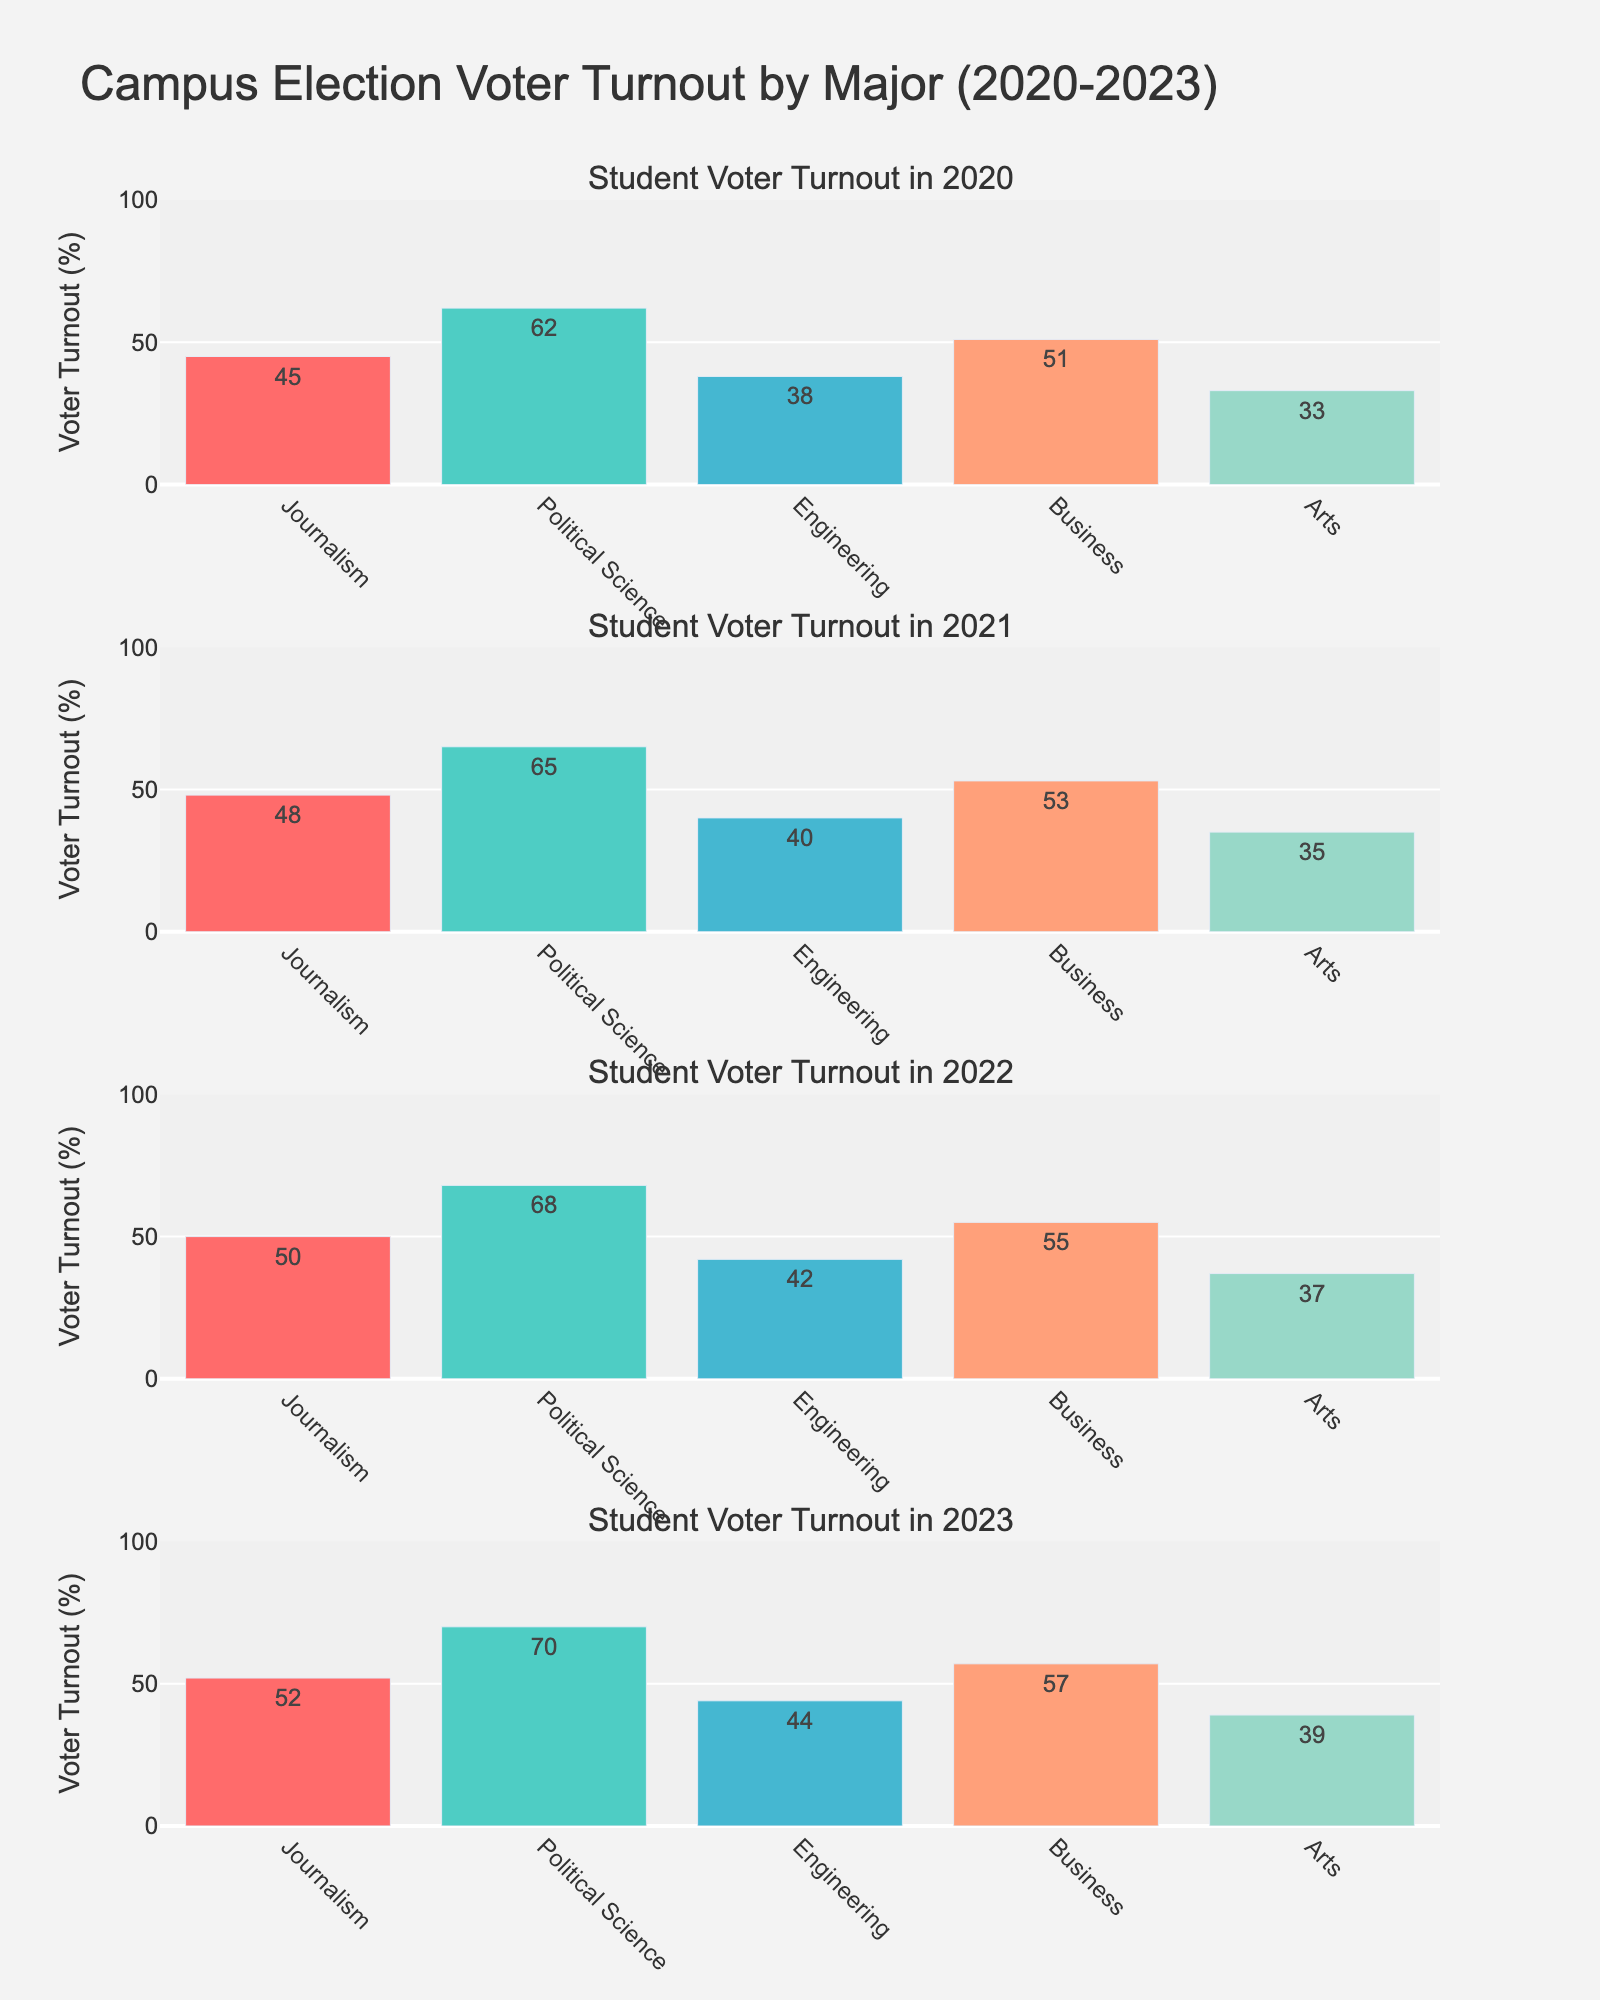What is the title of the figure? The title is usually located at the top center of the figure. Here, it's written as "Campus Election Voter Turnout by Major (2020-2023)".
Answer: Campus Election Voter Turnout by Major (2020-2023) How many total subplots are there? Each subplot represents a different year from 2020 to 2023. By counting these unique years, we see there are four subplots.
Answer: 4 Which major had the highest voter turnout in 2023? In the 2023 subplot, compare the heights of the bars. The tallest bar corresponds to Political Science.
Answer: Political Science What is the voter turnout percentage for Journalism in 2021? Look at the subplot for 2021 and the bar labeled Journalism. The text on the bar shows the voter turnout percentage.
Answer: 48% Compare the voter turnout for Arts between 2020 and 2023. Which year had higher turnout and by how much? Look at the bars for Arts in the 2020 and 2023 subplots. In 2020, the turnout is 33%, and in 2023, it is 39%. The difference is 39% - 33% = 6%.
Answer: 2023, 6% Which major had the least variation in voter turnout across the years? Compare the voter turnout bars for each major across all years. Engineering shows the least variation, ranging from 38% to 44%.
Answer: Engineering What is the average voter turnout for Business from 2020 to 2023? Sum the voter turnout percentages for Business each year (51 + 53 + 55 + 57) and divide by the number of years (4). The calculation is (51 + 53 + 55 + 57) / 4 = 54%.
Answer: 54% Did any major show a consistent increase in voter turnout from 2020 to 2023? Review the trends for each major's bars over the years. Political Science shows a consistent increase (62% in 2020, 65% in 2021, 68% in 2022, and 70% in 2023).
Answer: Political Science 